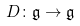<formula> <loc_0><loc_0><loc_500><loc_500>D \colon { \mathfrak { g } } \to { \mathfrak { g } }</formula> 